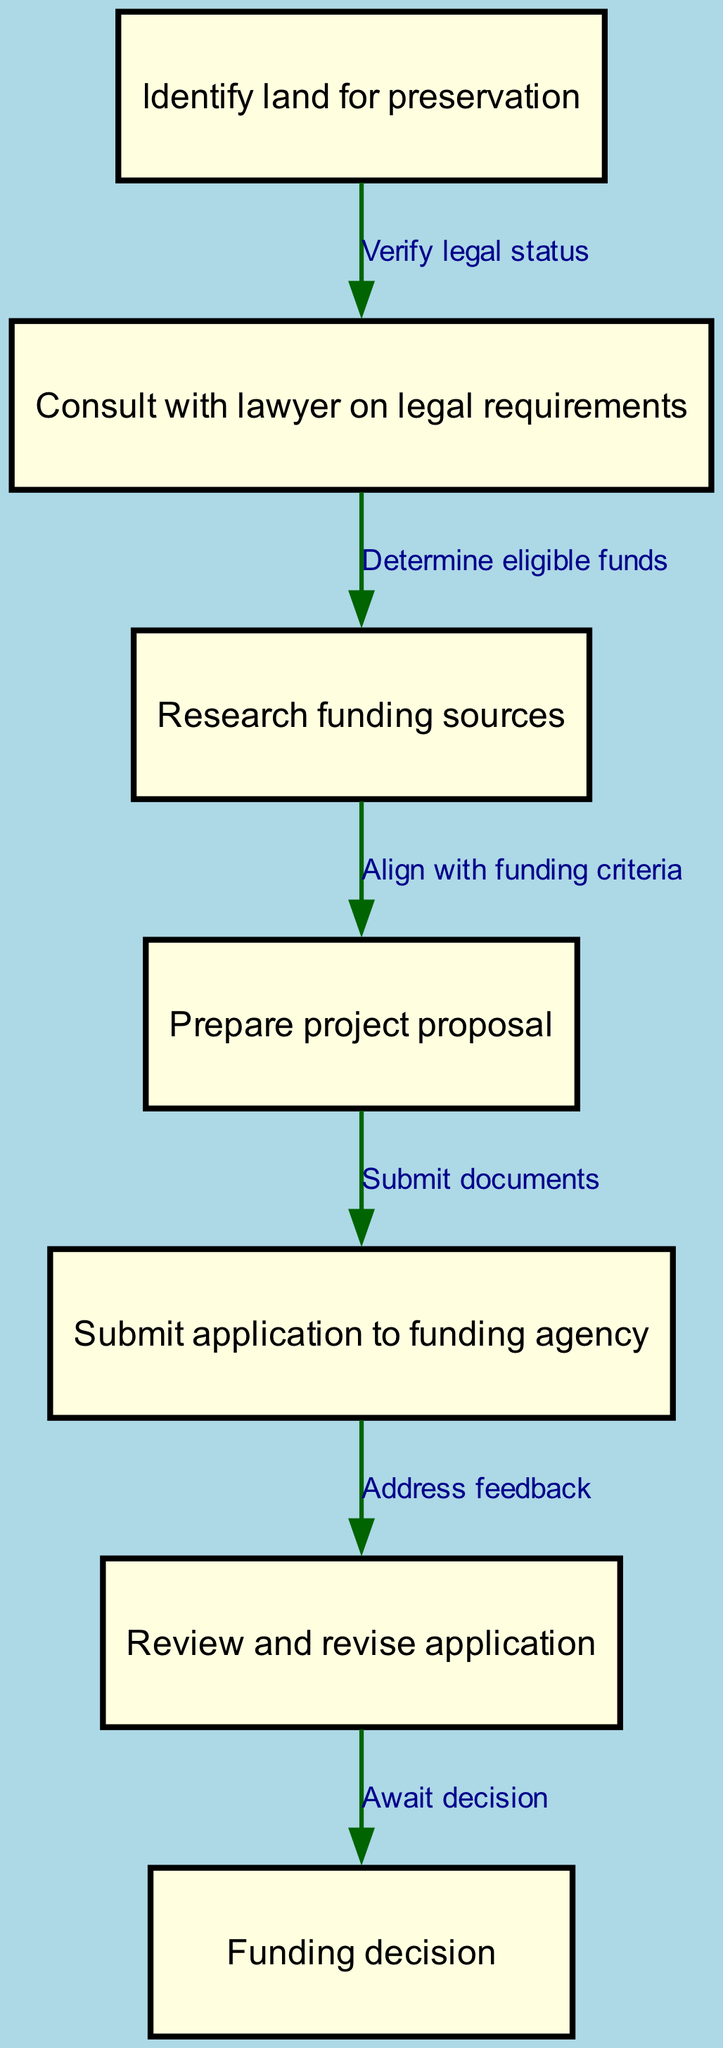What is the first step in the funding application process? The first step is labeled as "Identify land for preservation" in the diagram. This is the initial action required to start the funding application process.
Answer: Identify land for preservation How many nodes are present in the diagram? There are seven nodes depicted in the flowchart. Each node represents a specific step in the funding application process.
Answer: Seven What does the edge between node 1 and node 2 represent? The edge between node 1 ("Identify land for preservation") and node 2 ("Consult with lawyer on legal requirements") indicates the action of verifying the legal status of the identified land.
Answer: Verify legal status What is the last action listed in the flowchart? The last action indicated in the flowchart is "Await decision," which is the step following the application submission and review.
Answer: Await decision If the application is submitted, what comes next? After submitting the application to the funding agency, the next step is to address feedback as indicated by the edge leading to node 6. This step is crucial for improving the application.
Answer: Address feedback What must be determined before researching funding sources? Before researching funding sources, it is necessary to determine eligible funds, which is done after consulting with a lawyer on legal requirements. This is reflected in the flow from node 2 to node 3.
Answer: Determine eligible funds Which step requires aligning with funding criteria? The step that requires aligning with funding criteria is "Prepare project proposal." This is essential to ensure the proposal meets the expectations of potential funding sources.
Answer: Prepare project proposal What is the relationship between the submission of the application and revision process? The relationship is that after the application is submitted, there is a subsequent action to "Review and revise application," allowing for necessary adjustments based on feedback.
Answer: Review and revise application 